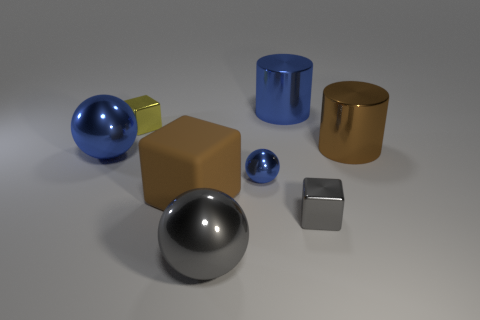Add 1 rubber blocks. How many objects exist? 9 Subtract all cylinders. How many objects are left? 6 Subtract all tiny yellow things. Subtract all metal cubes. How many objects are left? 5 Add 7 yellow metallic objects. How many yellow metallic objects are left? 8 Add 5 large metal balls. How many large metal balls exist? 7 Subtract 1 yellow blocks. How many objects are left? 7 